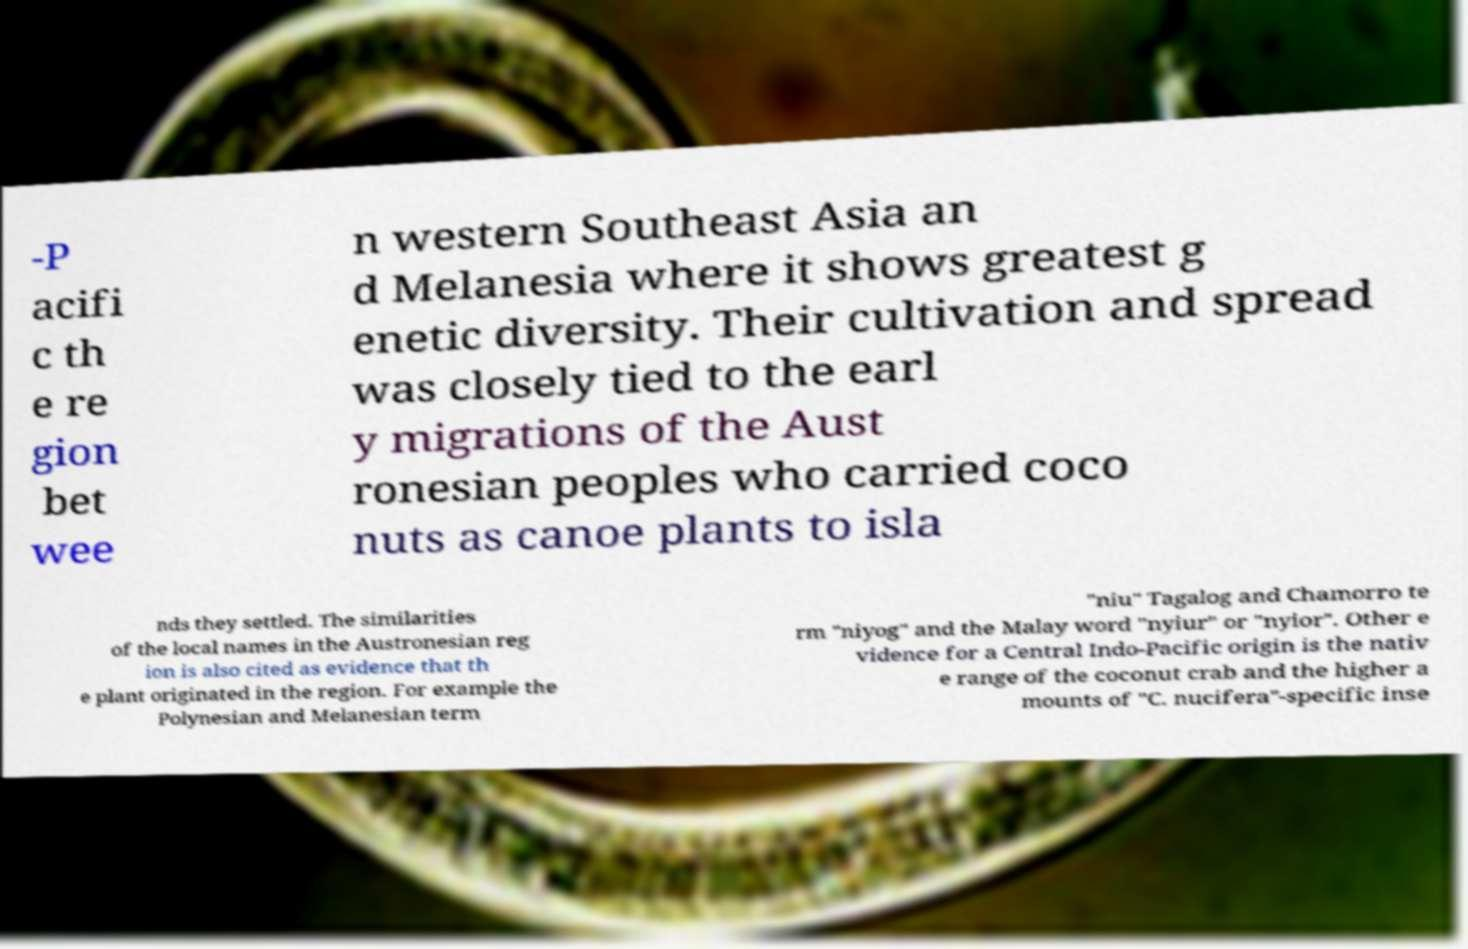Can you read and provide the text displayed in the image?This photo seems to have some interesting text. Can you extract and type it out for me? -P acifi c th e re gion bet wee n western Southeast Asia an d Melanesia where it shows greatest g enetic diversity. Their cultivation and spread was closely tied to the earl y migrations of the Aust ronesian peoples who carried coco nuts as canoe plants to isla nds they settled. The similarities of the local names in the Austronesian reg ion is also cited as evidence that th e plant originated in the region. For example the Polynesian and Melanesian term "niu" Tagalog and Chamorro te rm "niyog" and the Malay word "nyiur" or "nyior". Other e vidence for a Central Indo-Pacific origin is the nativ e range of the coconut crab and the higher a mounts of "C. nucifera"-specific inse 